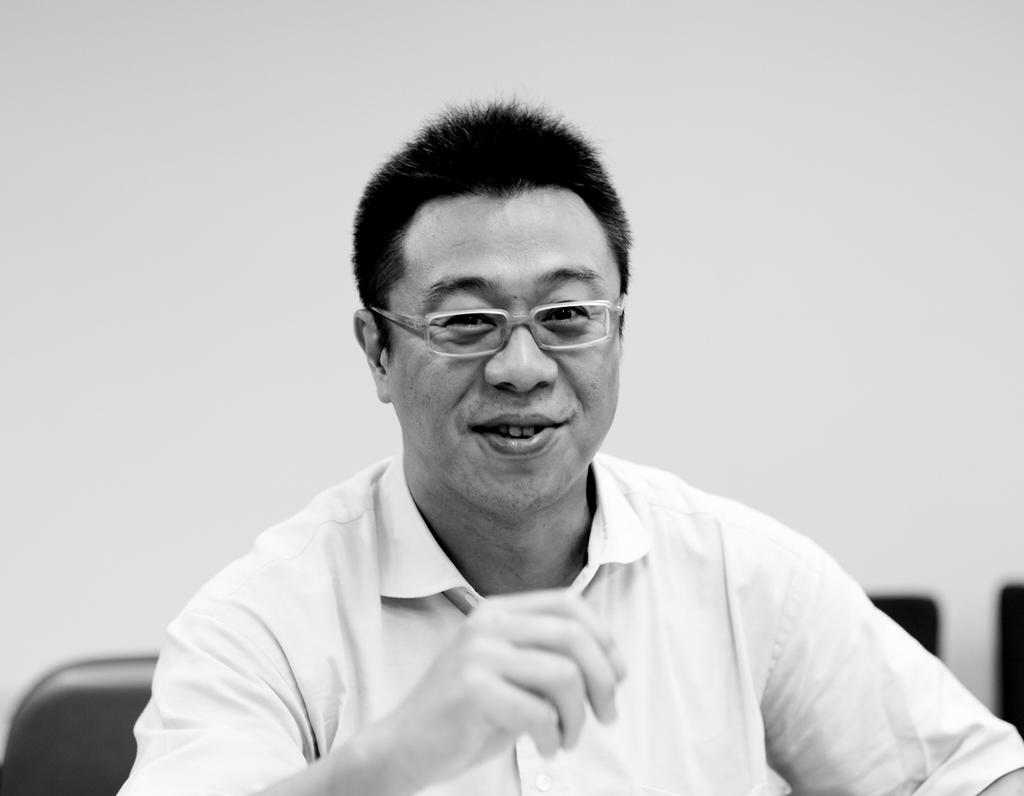Who is present in the image? There is a person in the image. What can be observed about the person's appearance? The person is wearing glasses (specs). What is the person's facial expression? The person is smiling. What is visible in the background of the image? There is a wall in the background of the image. How is the image presented in terms of color? The image is black and white. What type of stocking is the person wearing in the image? There is no mention of stockings in the image, so it cannot be determined if the person is wearing any. 